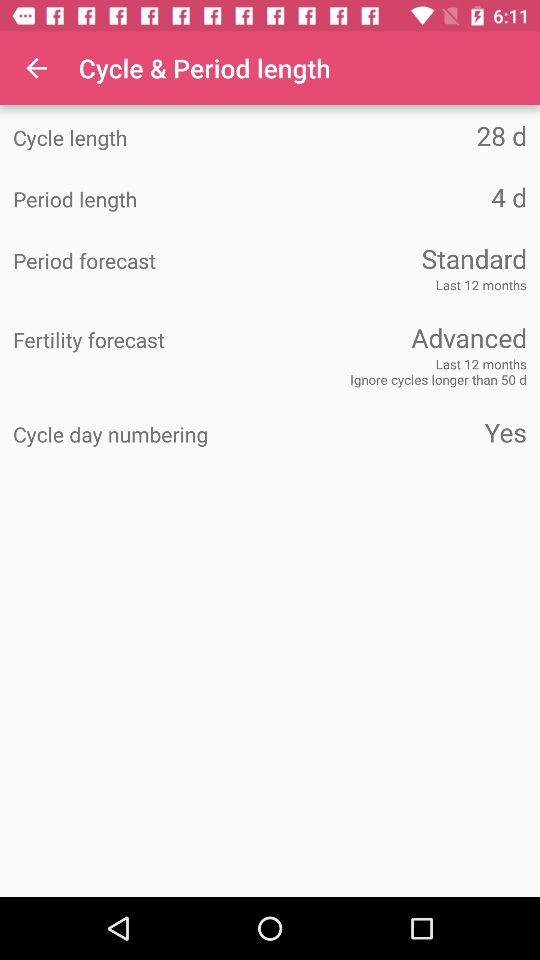Which version of the application is this?
When the provided information is insufficient, respond with <no answer>. <no answer> 